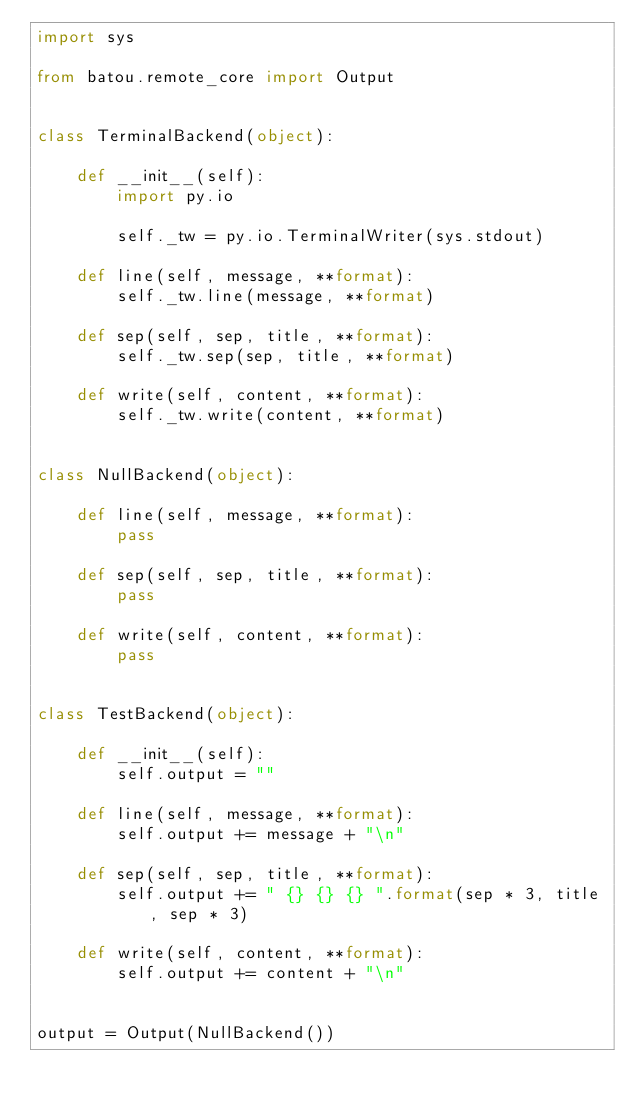<code> <loc_0><loc_0><loc_500><loc_500><_Python_>import sys

from batou.remote_core import Output


class TerminalBackend(object):

    def __init__(self):
        import py.io

        self._tw = py.io.TerminalWriter(sys.stdout)

    def line(self, message, **format):
        self._tw.line(message, **format)

    def sep(self, sep, title, **format):
        self._tw.sep(sep, title, **format)

    def write(self, content, **format):
        self._tw.write(content, **format)


class NullBackend(object):

    def line(self, message, **format):
        pass

    def sep(self, sep, title, **format):
        pass

    def write(self, content, **format):
        pass


class TestBackend(object):

    def __init__(self):
        self.output = ""

    def line(self, message, **format):
        self.output += message + "\n"

    def sep(self, sep, title, **format):
        self.output += " {} {} {} ".format(sep * 3, title, sep * 3)

    def write(self, content, **format):
        self.output += content + "\n"


output = Output(NullBackend())
</code> 